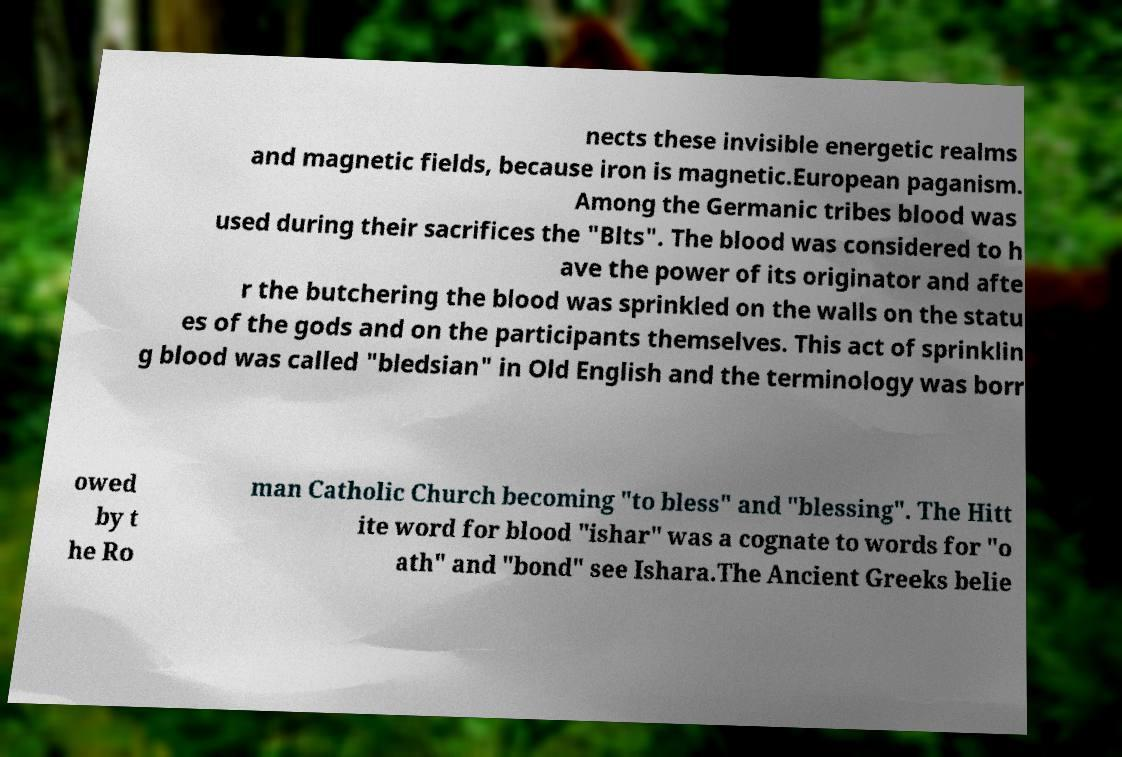What messages or text are displayed in this image? I need them in a readable, typed format. nects these invisible energetic realms and magnetic fields, because iron is magnetic.European paganism. Among the Germanic tribes blood was used during their sacrifices the "Blts". The blood was considered to h ave the power of its originator and afte r the butchering the blood was sprinkled on the walls on the statu es of the gods and on the participants themselves. This act of sprinklin g blood was called "bledsian" in Old English and the terminology was borr owed by t he Ro man Catholic Church becoming "to bless" and "blessing". The Hitt ite word for blood "ishar" was a cognate to words for "o ath" and "bond" see Ishara.The Ancient Greeks belie 